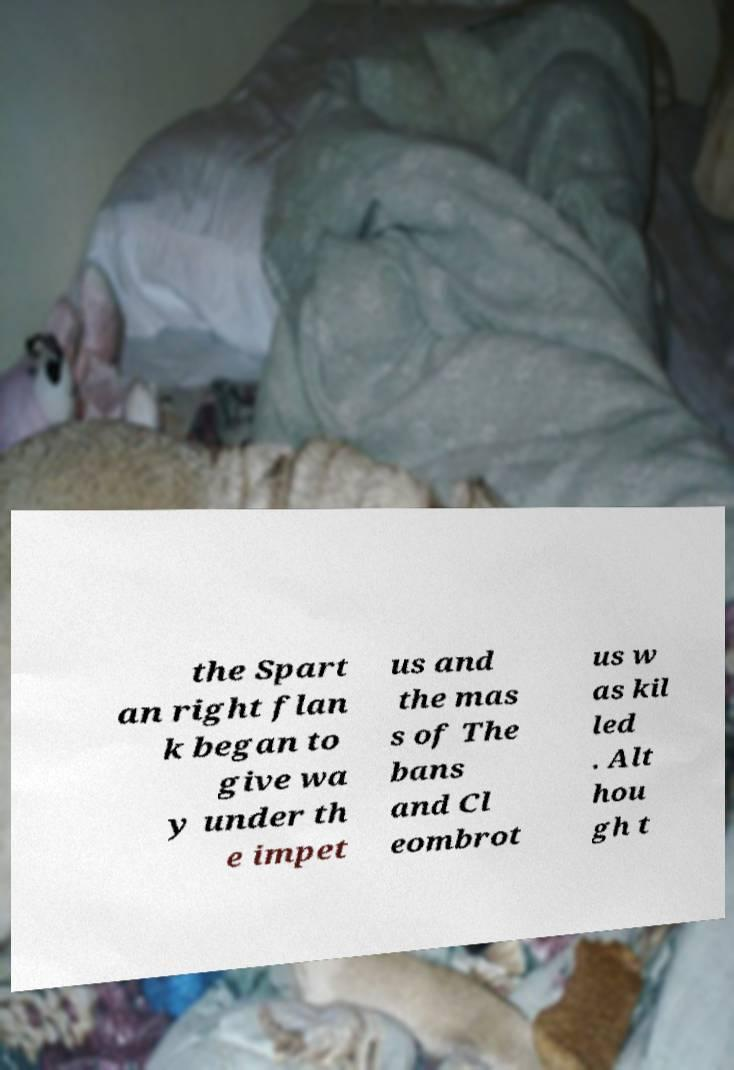What messages or text are displayed in this image? I need them in a readable, typed format. the Spart an right flan k began to give wa y under th e impet us and the mas s of The bans and Cl eombrot us w as kil led . Alt hou gh t 